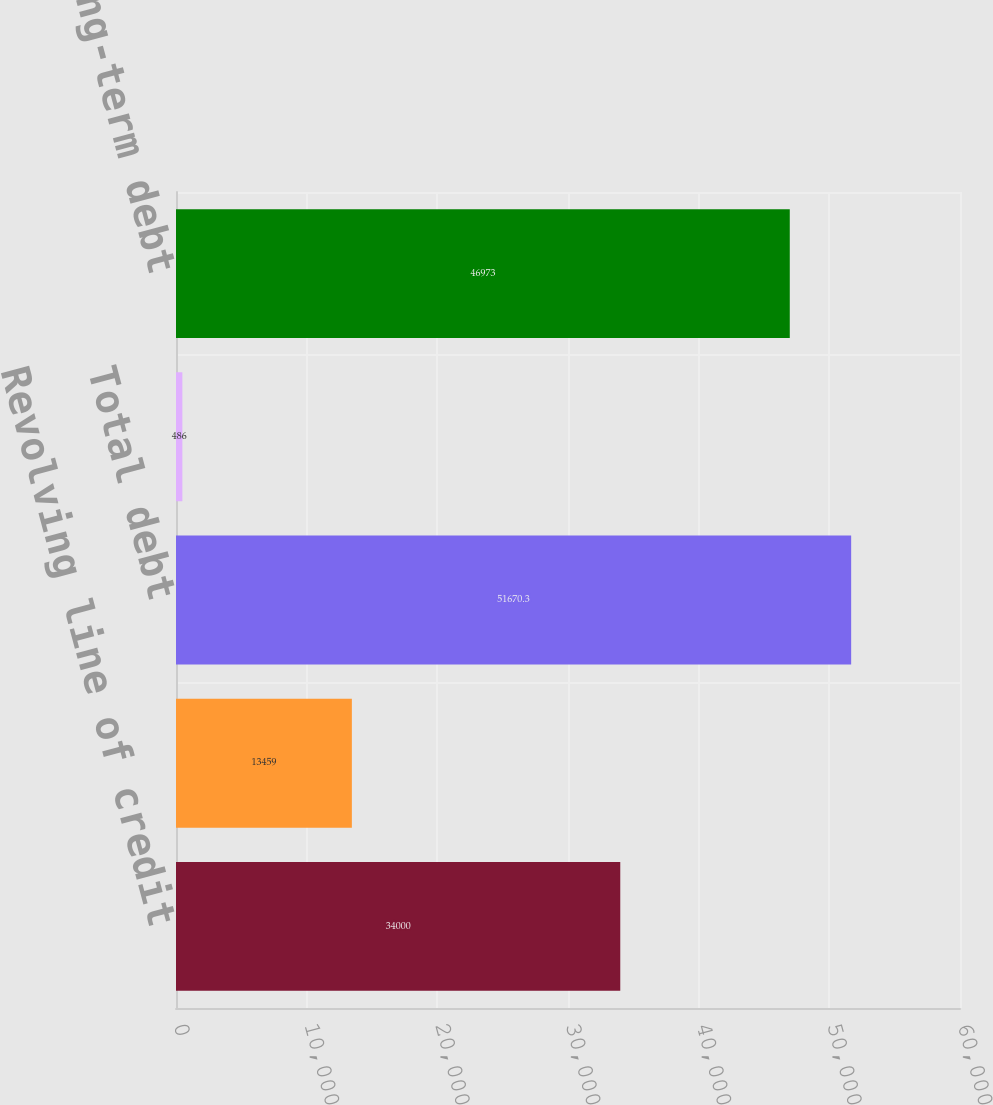Convert chart. <chart><loc_0><loc_0><loc_500><loc_500><bar_chart><fcel>Revolving line of credit<fcel>Mortgage notes payable<fcel>Total debt<fcel>Less current maturities<fcel>Long-term debt<nl><fcel>34000<fcel>13459<fcel>51670.3<fcel>486<fcel>46973<nl></chart> 